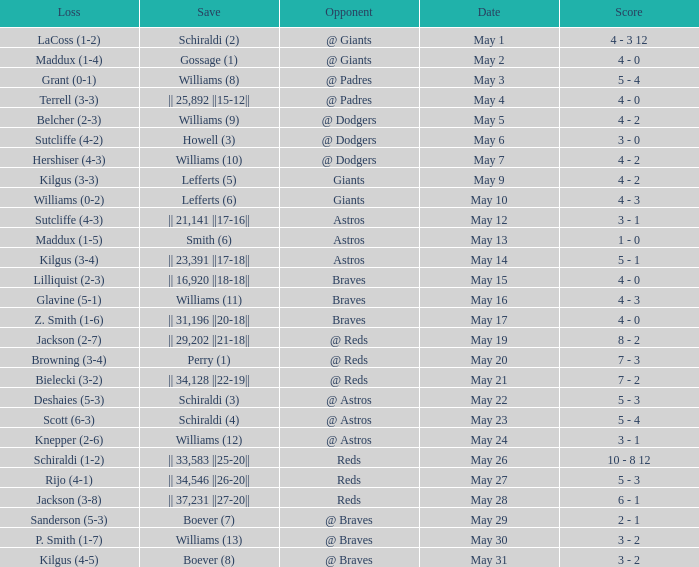Name the loss with save of || 23,391 ||17-18||? Kilgus (3-4). 